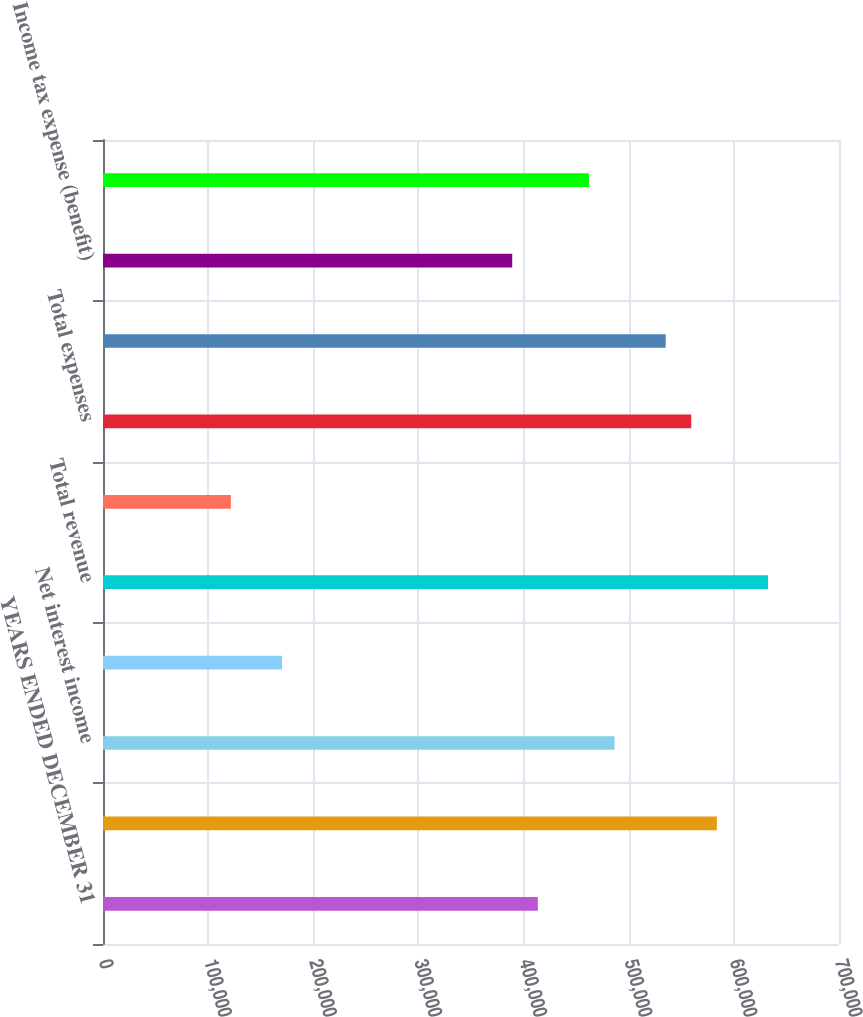<chart> <loc_0><loc_0><loc_500><loc_500><bar_chart><fcel>YEARS ENDED DECEMBER 31<fcel>Total fee revenue<fcel>Net interest income<fcel>Gains (losses) related to<fcel>Total revenue<fcel>Provision for loan losses<fcel>Total expenses<fcel>Income before income tax<fcel>Income tax expense (benefit)<fcel>Net income<nl><fcel>413545<fcel>583827<fcel>486523<fcel>170284<fcel>632480<fcel>121631<fcel>559501<fcel>535175<fcel>389219<fcel>462197<nl></chart> 